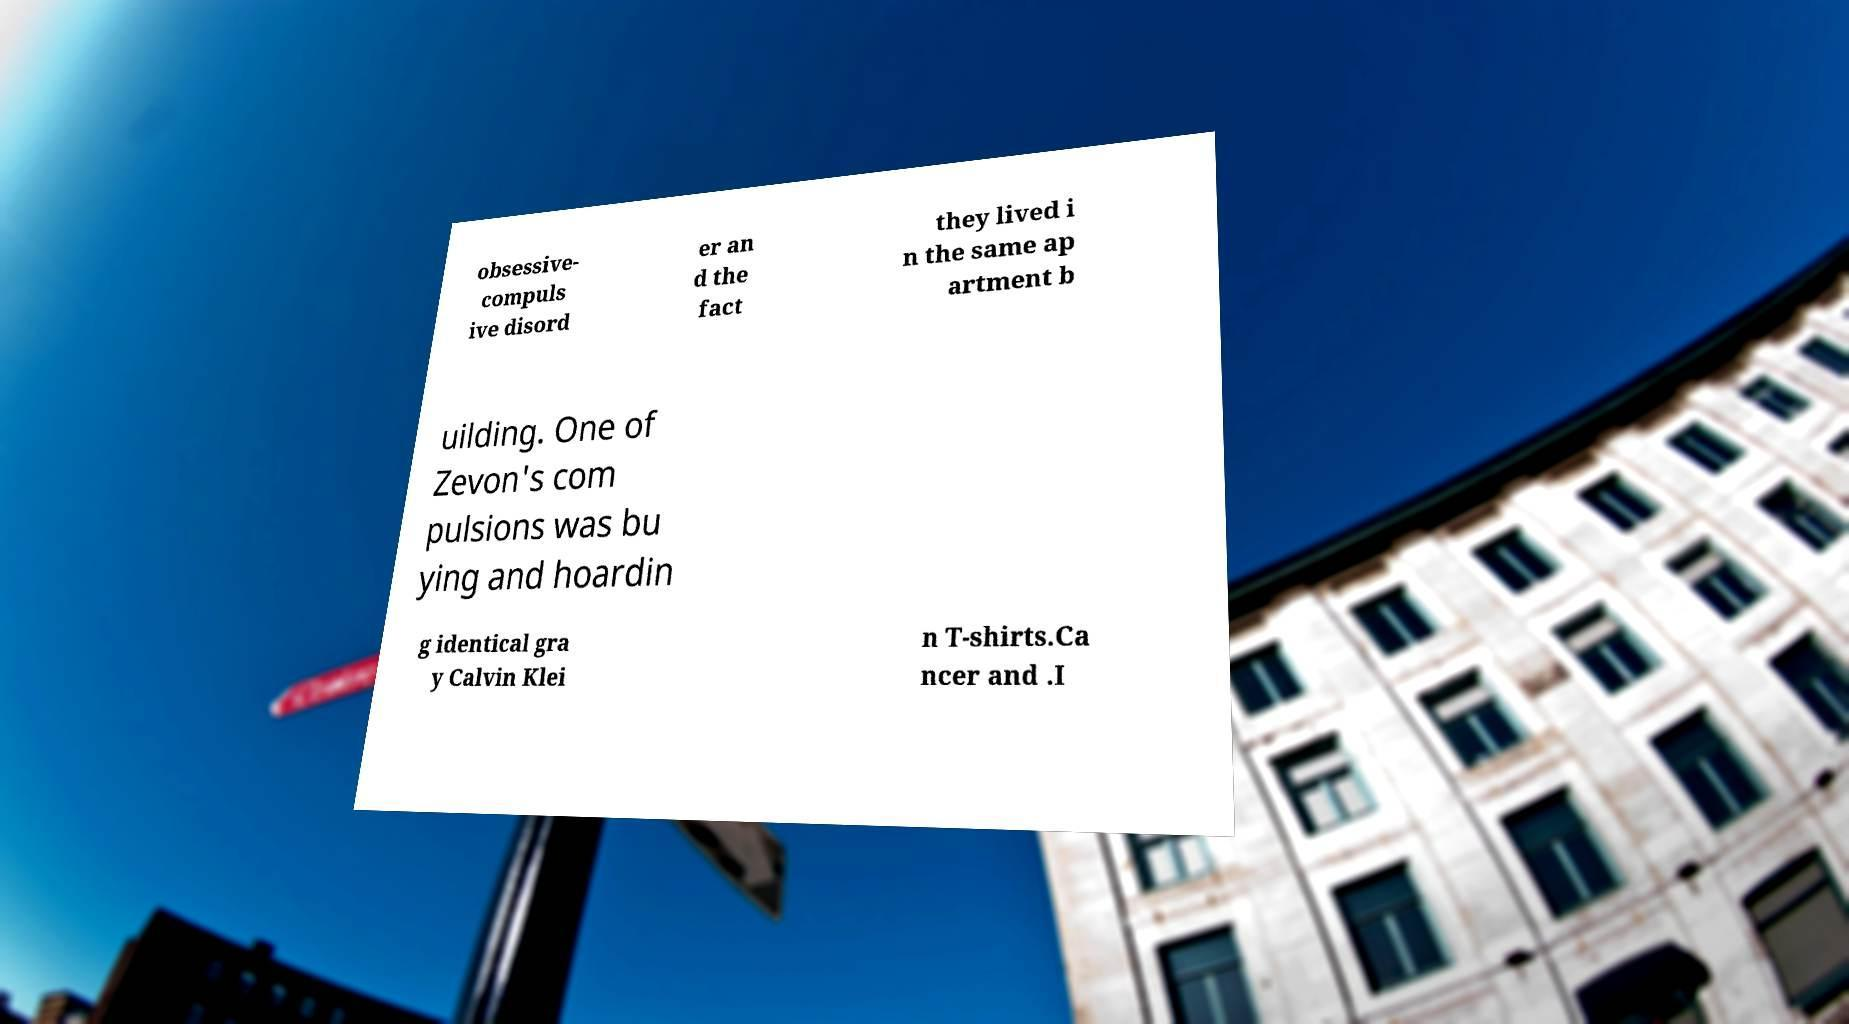What messages or text are displayed in this image? I need them in a readable, typed format. obsessive- compuls ive disord er an d the fact they lived i n the same ap artment b uilding. One of Zevon's com pulsions was bu ying and hoardin g identical gra y Calvin Klei n T-shirts.Ca ncer and .I 